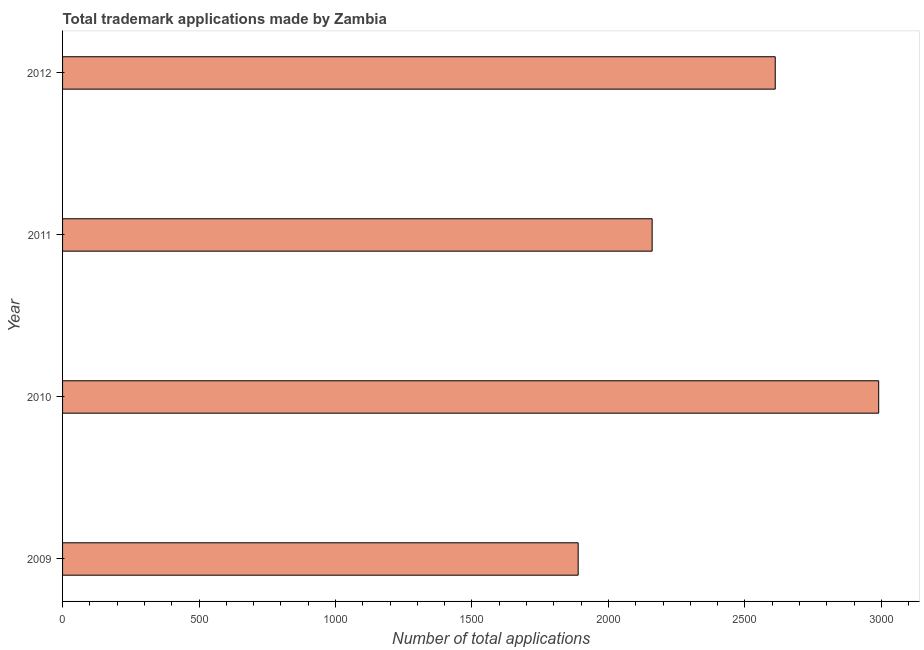Does the graph contain any zero values?
Provide a succinct answer. No. Does the graph contain grids?
Offer a very short reply. No. What is the title of the graph?
Provide a short and direct response. Total trademark applications made by Zambia. What is the label or title of the X-axis?
Offer a terse response. Number of total applications. What is the number of trademark applications in 2010?
Provide a short and direct response. 2990. Across all years, what is the maximum number of trademark applications?
Make the answer very short. 2990. Across all years, what is the minimum number of trademark applications?
Your answer should be compact. 1889. In which year was the number of trademark applications minimum?
Make the answer very short. 2009. What is the sum of the number of trademark applications?
Provide a short and direct response. 9650. What is the difference between the number of trademark applications in 2009 and 2010?
Keep it short and to the point. -1101. What is the average number of trademark applications per year?
Your answer should be compact. 2412. What is the median number of trademark applications?
Give a very brief answer. 2385.5. In how many years, is the number of trademark applications greater than 200 ?
Keep it short and to the point. 4. What is the ratio of the number of trademark applications in 2009 to that in 2010?
Offer a terse response. 0.63. Is the number of trademark applications in 2011 less than that in 2012?
Provide a succinct answer. Yes. Is the difference between the number of trademark applications in 2009 and 2010 greater than the difference between any two years?
Give a very brief answer. Yes. What is the difference between the highest and the second highest number of trademark applications?
Offer a terse response. 379. What is the difference between the highest and the lowest number of trademark applications?
Your response must be concise. 1101. In how many years, is the number of trademark applications greater than the average number of trademark applications taken over all years?
Provide a succinct answer. 2. What is the Number of total applications of 2009?
Make the answer very short. 1889. What is the Number of total applications in 2010?
Offer a very short reply. 2990. What is the Number of total applications in 2011?
Give a very brief answer. 2160. What is the Number of total applications in 2012?
Offer a terse response. 2611. What is the difference between the Number of total applications in 2009 and 2010?
Your answer should be compact. -1101. What is the difference between the Number of total applications in 2009 and 2011?
Your answer should be compact. -271. What is the difference between the Number of total applications in 2009 and 2012?
Your response must be concise. -722. What is the difference between the Number of total applications in 2010 and 2011?
Ensure brevity in your answer.  830. What is the difference between the Number of total applications in 2010 and 2012?
Offer a terse response. 379. What is the difference between the Number of total applications in 2011 and 2012?
Offer a terse response. -451. What is the ratio of the Number of total applications in 2009 to that in 2010?
Your response must be concise. 0.63. What is the ratio of the Number of total applications in 2009 to that in 2012?
Your answer should be very brief. 0.72. What is the ratio of the Number of total applications in 2010 to that in 2011?
Your response must be concise. 1.38. What is the ratio of the Number of total applications in 2010 to that in 2012?
Your answer should be very brief. 1.15. What is the ratio of the Number of total applications in 2011 to that in 2012?
Provide a succinct answer. 0.83. 